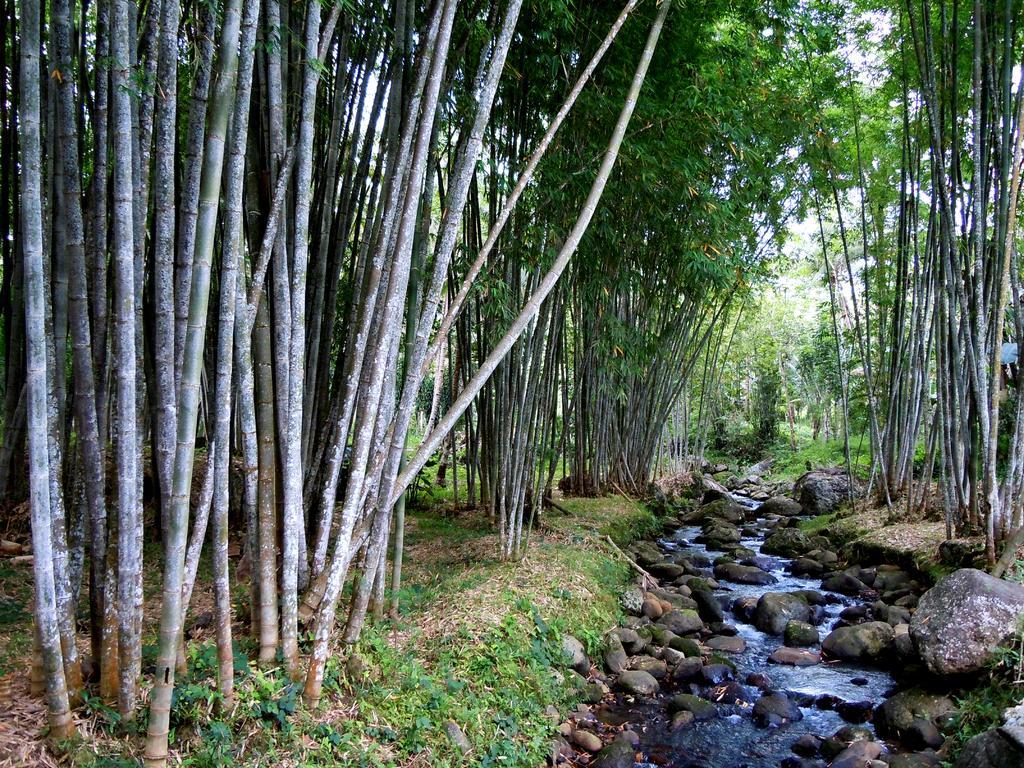Describe this image in one or two sentences. In this picture we can see water and rocks. Behind the rocks there are trees and the sky. 